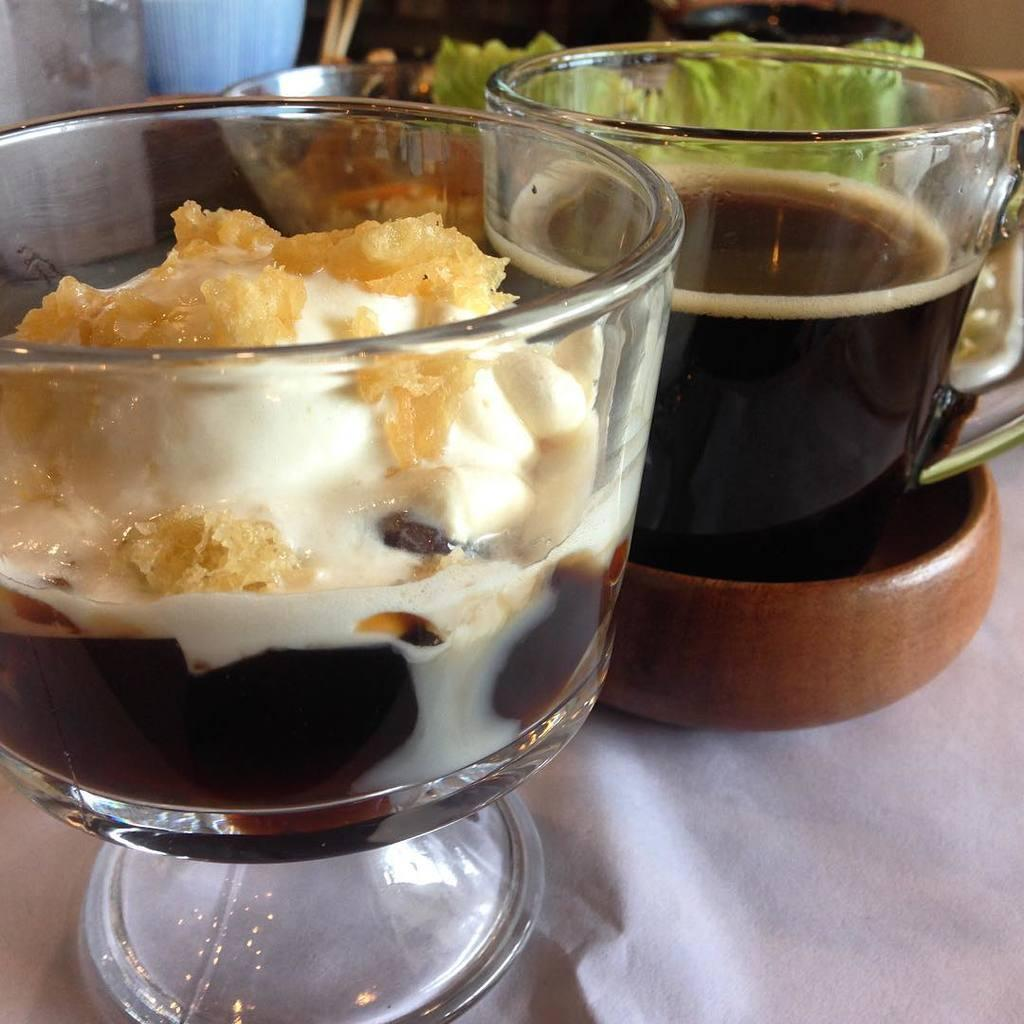What objects are present in the image? There are jars in the image. What is inside the jars? There is food and liquids in the jars. What country is being celebrated in the image? There is no indication of a country or celebration in the image; it only shows jars with food and liquids. 